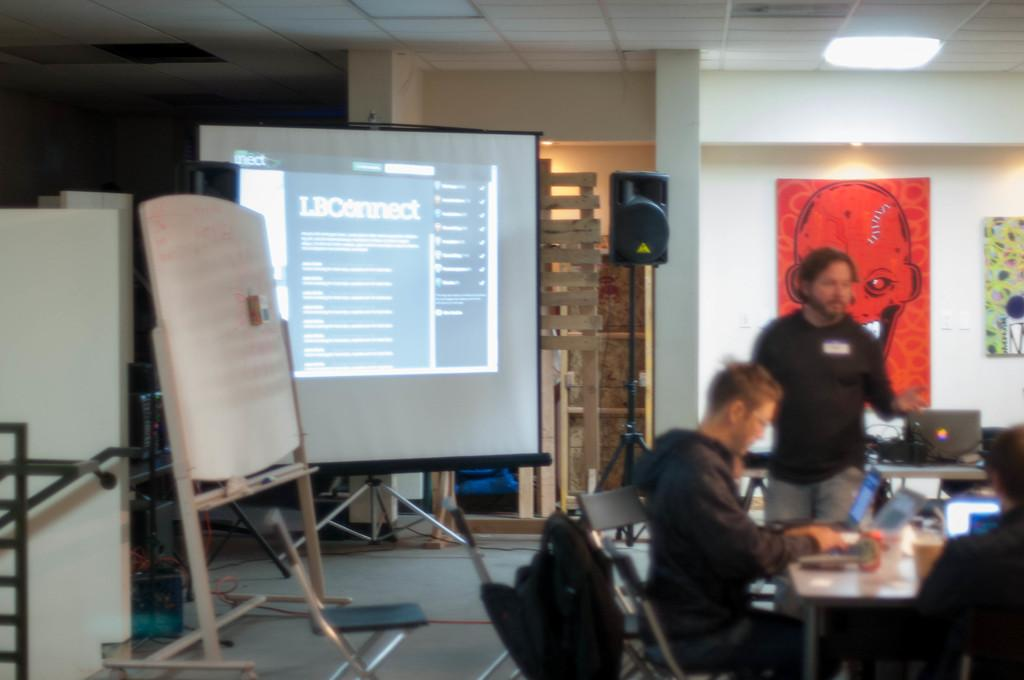What is displayed on the left side of the image? There is a projector display in the left side of the image. Who is present in the right side of the image? A man is standing in the right side of the image. What is the other man in the image doing? Another man is sitting and working on a laptop in the image. What can be seen at the top of the image? There is a light at the top of the image. How many friends does the man standing in the image have? The image does not provide information about the man's friends, so it cannot be determined from the image. Is there a stranger present in the image? The image does not mention any strangers, only the two men who are present. 